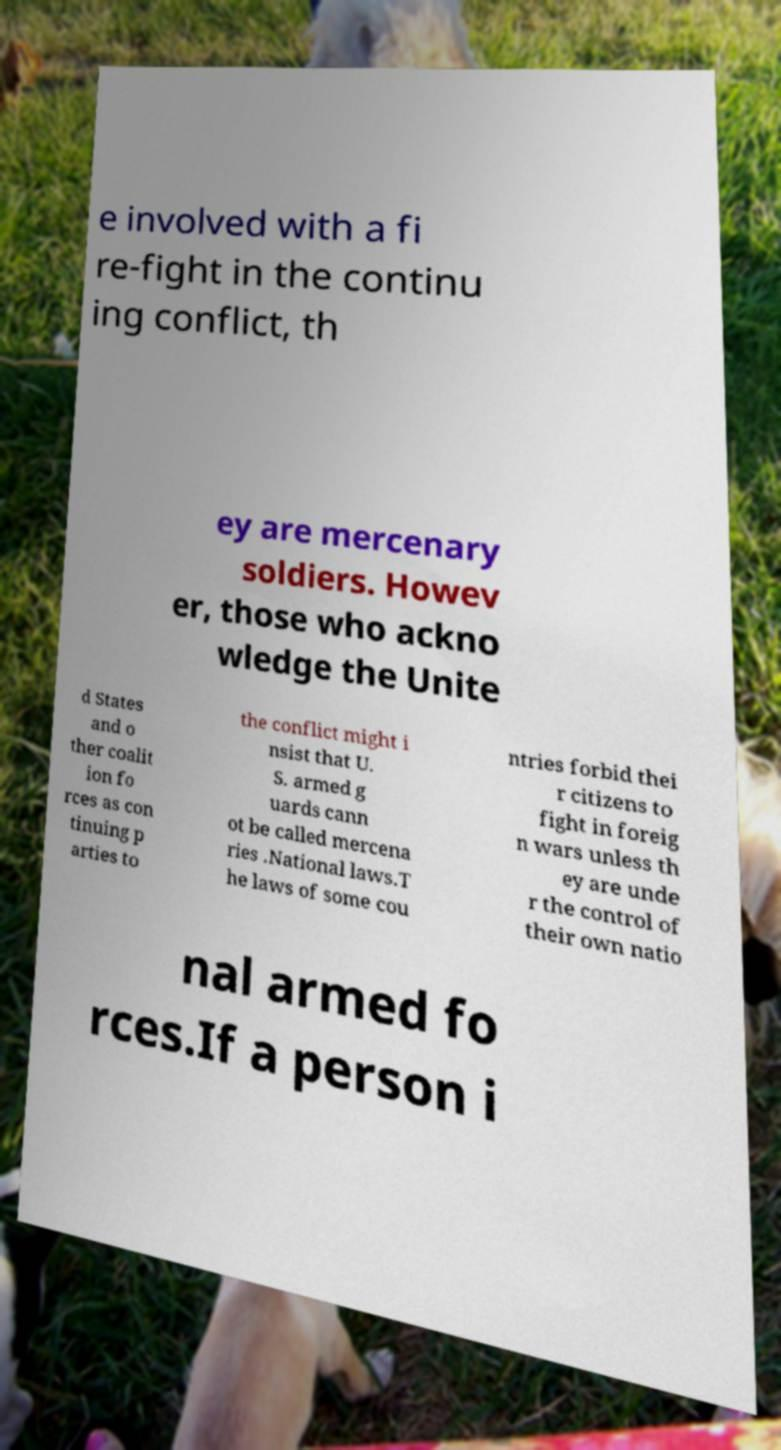I need the written content from this picture converted into text. Can you do that? e involved with a fi re-fight in the continu ing conflict, th ey are mercenary soldiers. Howev er, those who ackno wledge the Unite d States and o ther coalit ion fo rces as con tinuing p arties to the conflict might i nsist that U. S. armed g uards cann ot be called mercena ries .National laws.T he laws of some cou ntries forbid thei r citizens to fight in foreig n wars unless th ey are unde r the control of their own natio nal armed fo rces.If a person i 